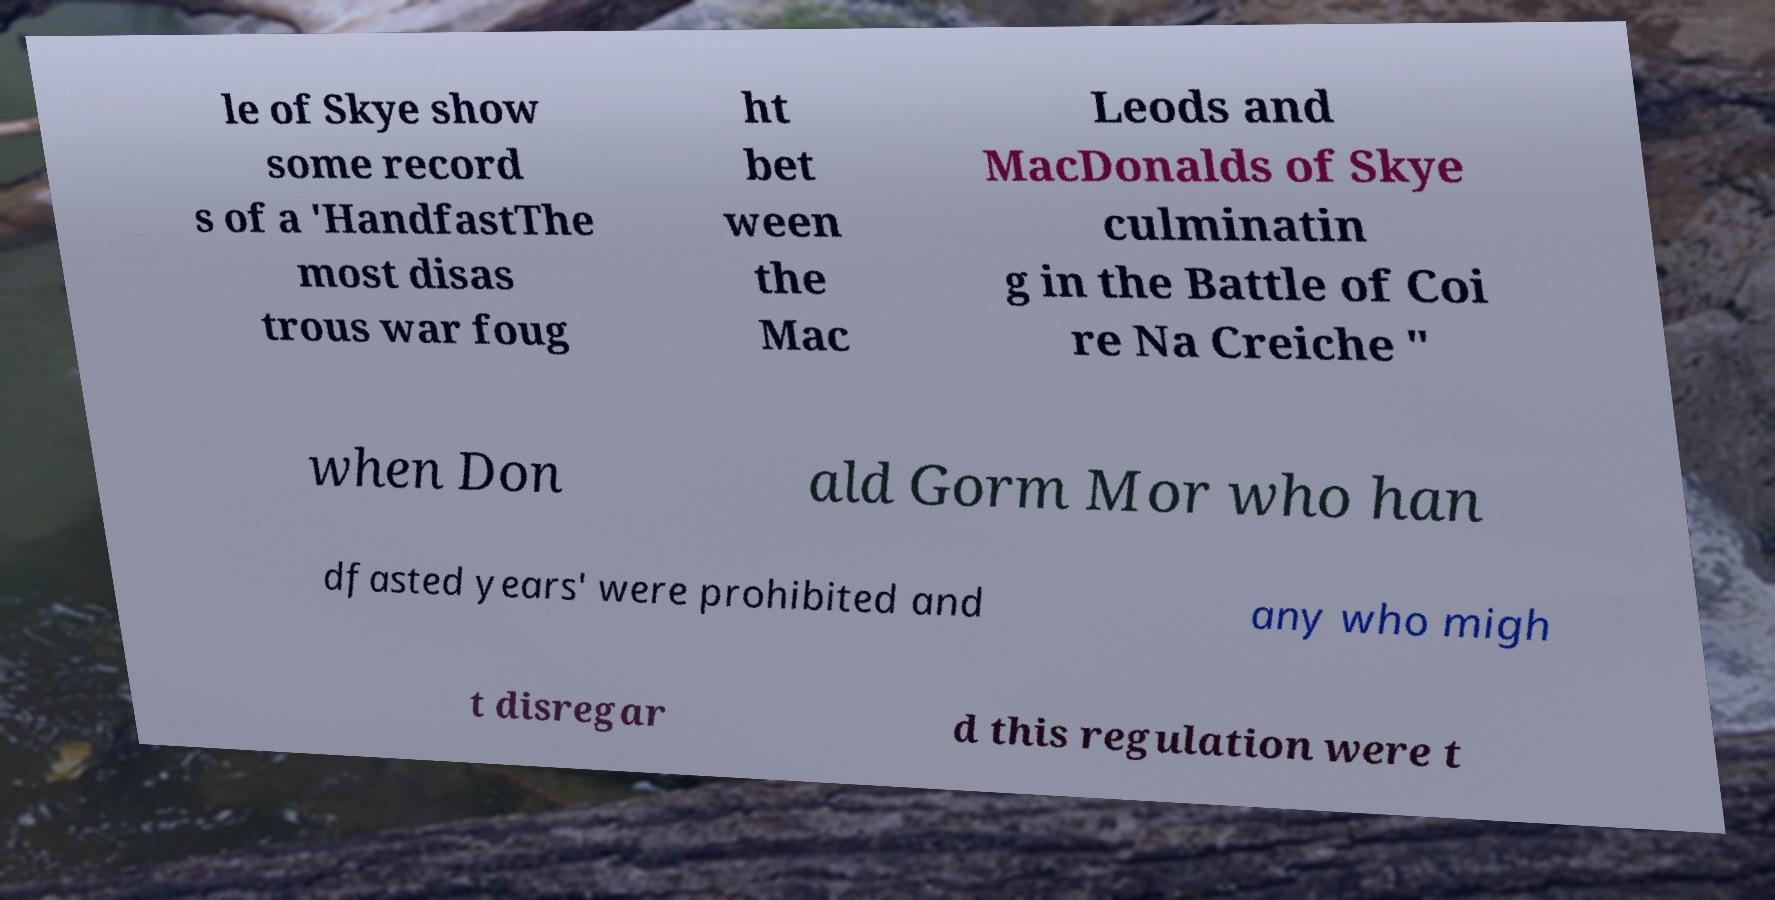Can you read and provide the text displayed in the image?This photo seems to have some interesting text. Can you extract and type it out for me? le of Skye show some record s of a 'HandfastThe most disas trous war foug ht bet ween the Mac Leods and MacDonalds of Skye culminatin g in the Battle of Coi re Na Creiche " when Don ald Gorm Mor who han dfasted years' were prohibited and any who migh t disregar d this regulation were t 